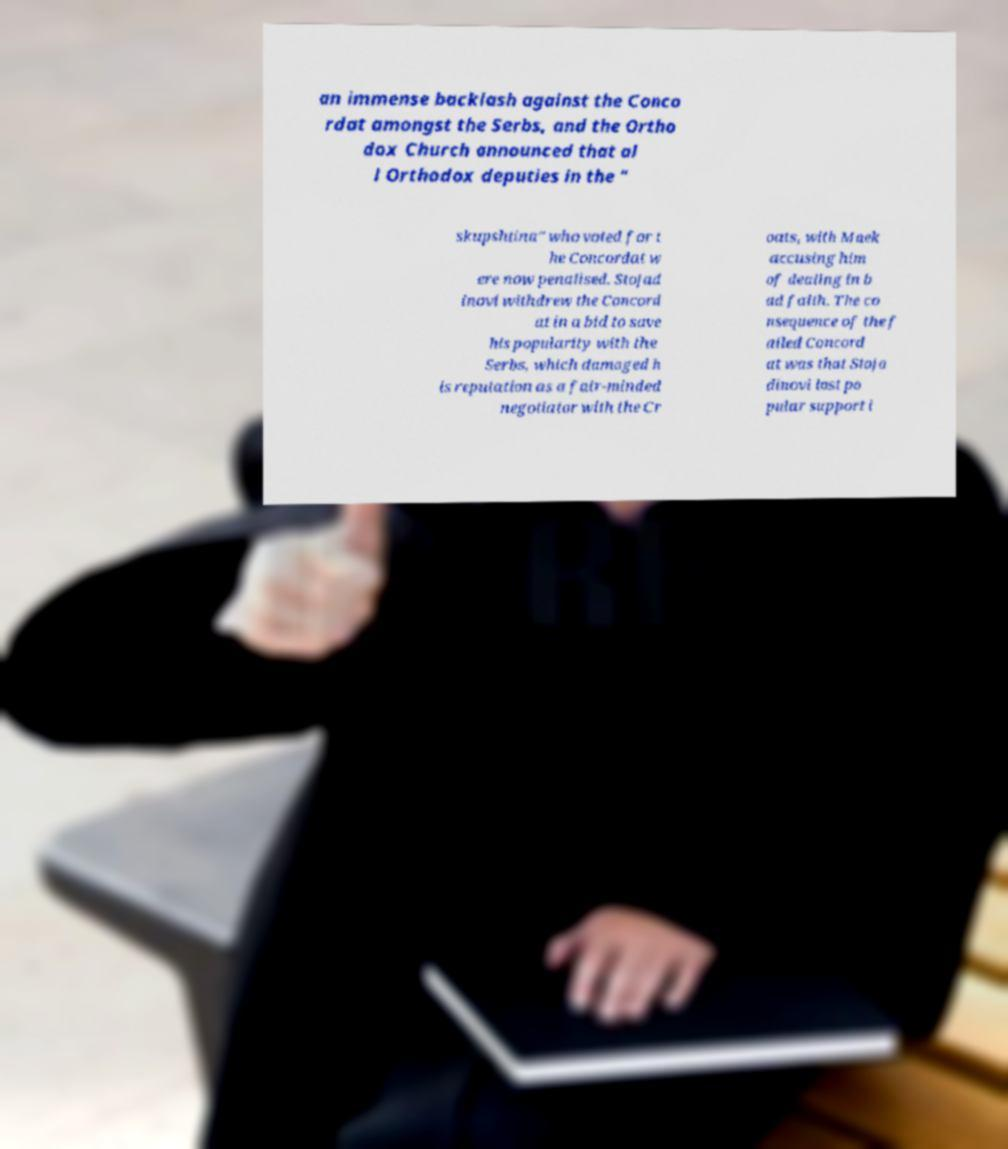There's text embedded in this image that I need extracted. Can you transcribe it verbatim? an immense backlash against the Conco rdat amongst the Serbs, and the Ortho dox Church announced that al l Orthodox deputies in the " skupshtina" who voted for t he Concordat w ere now penalised. Stojad inovi withdrew the Concord at in a bid to save his popularity with the Serbs, which damaged h is reputation as a fair-minded negotiator with the Cr oats, with Maek accusing him of dealing in b ad faith. The co nsequence of the f ailed Concord at was that Stoja dinovi lost po pular support i 